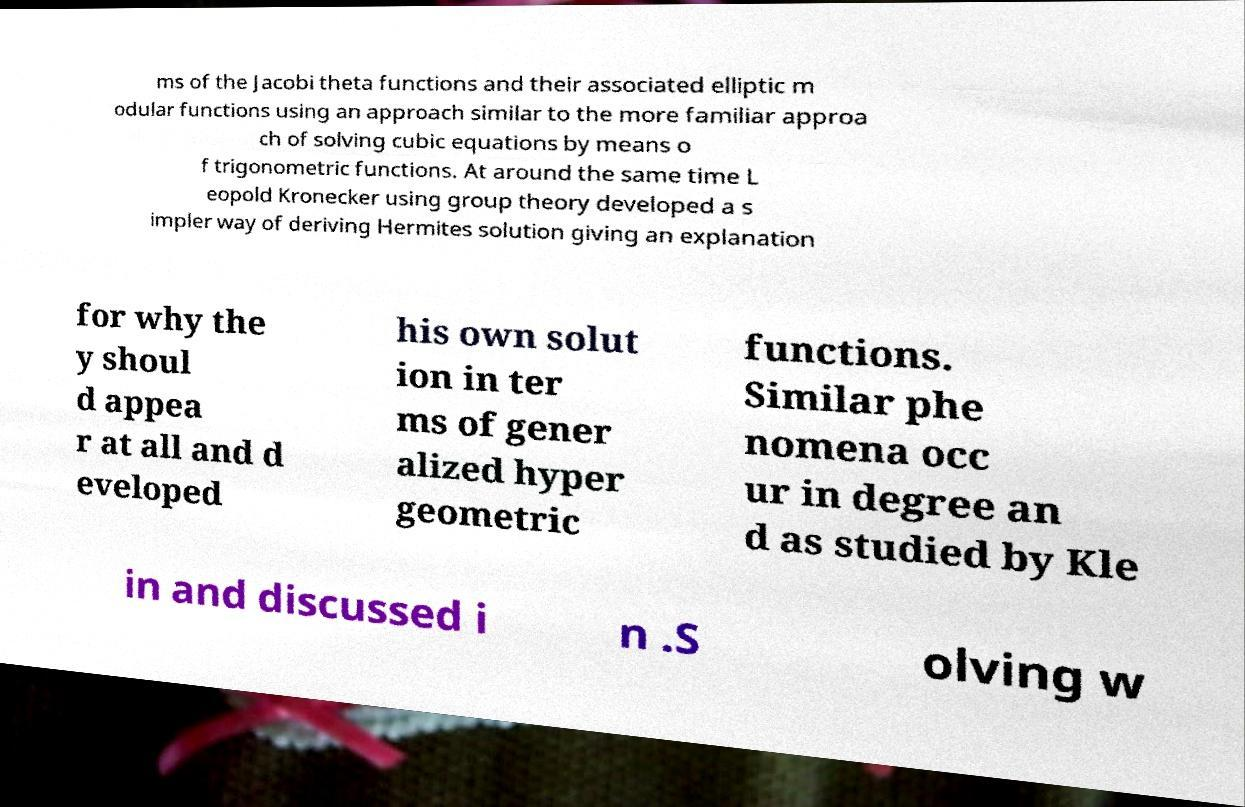There's text embedded in this image that I need extracted. Can you transcribe it verbatim? ms of the Jacobi theta functions and their associated elliptic m odular functions using an approach similar to the more familiar approa ch of solving cubic equations by means o f trigonometric functions. At around the same time L eopold Kronecker using group theory developed a s impler way of deriving Hermites solution giving an explanation for why the y shoul d appea r at all and d eveloped his own solut ion in ter ms of gener alized hyper geometric functions. Similar phe nomena occ ur in degree an d as studied by Kle in and discussed i n .S olving w 